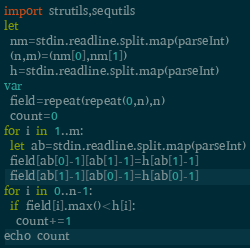<code> <loc_0><loc_0><loc_500><loc_500><_Nim_>import strutils,sequtils
let
 nm=stdin.readline.split.map(parseInt)
 (n,m)=(nm[0],nm[1])
 h=stdin.readline.split.map(parseInt)
var
 field=repeat(repeat(0,n),n)
 count=0
for i in 1..m:
 let ab=stdin.readline.split.map(parseInt)
 field[ab[0]-1][ab[1]-1]=h[ab[1]-1]
 field[ab[1]-1][ab[0]-1]=h[ab[0]-1]
for i in 0..n-1:
 if field[i].max()<h[i]:
  count+=1
echo count</code> 